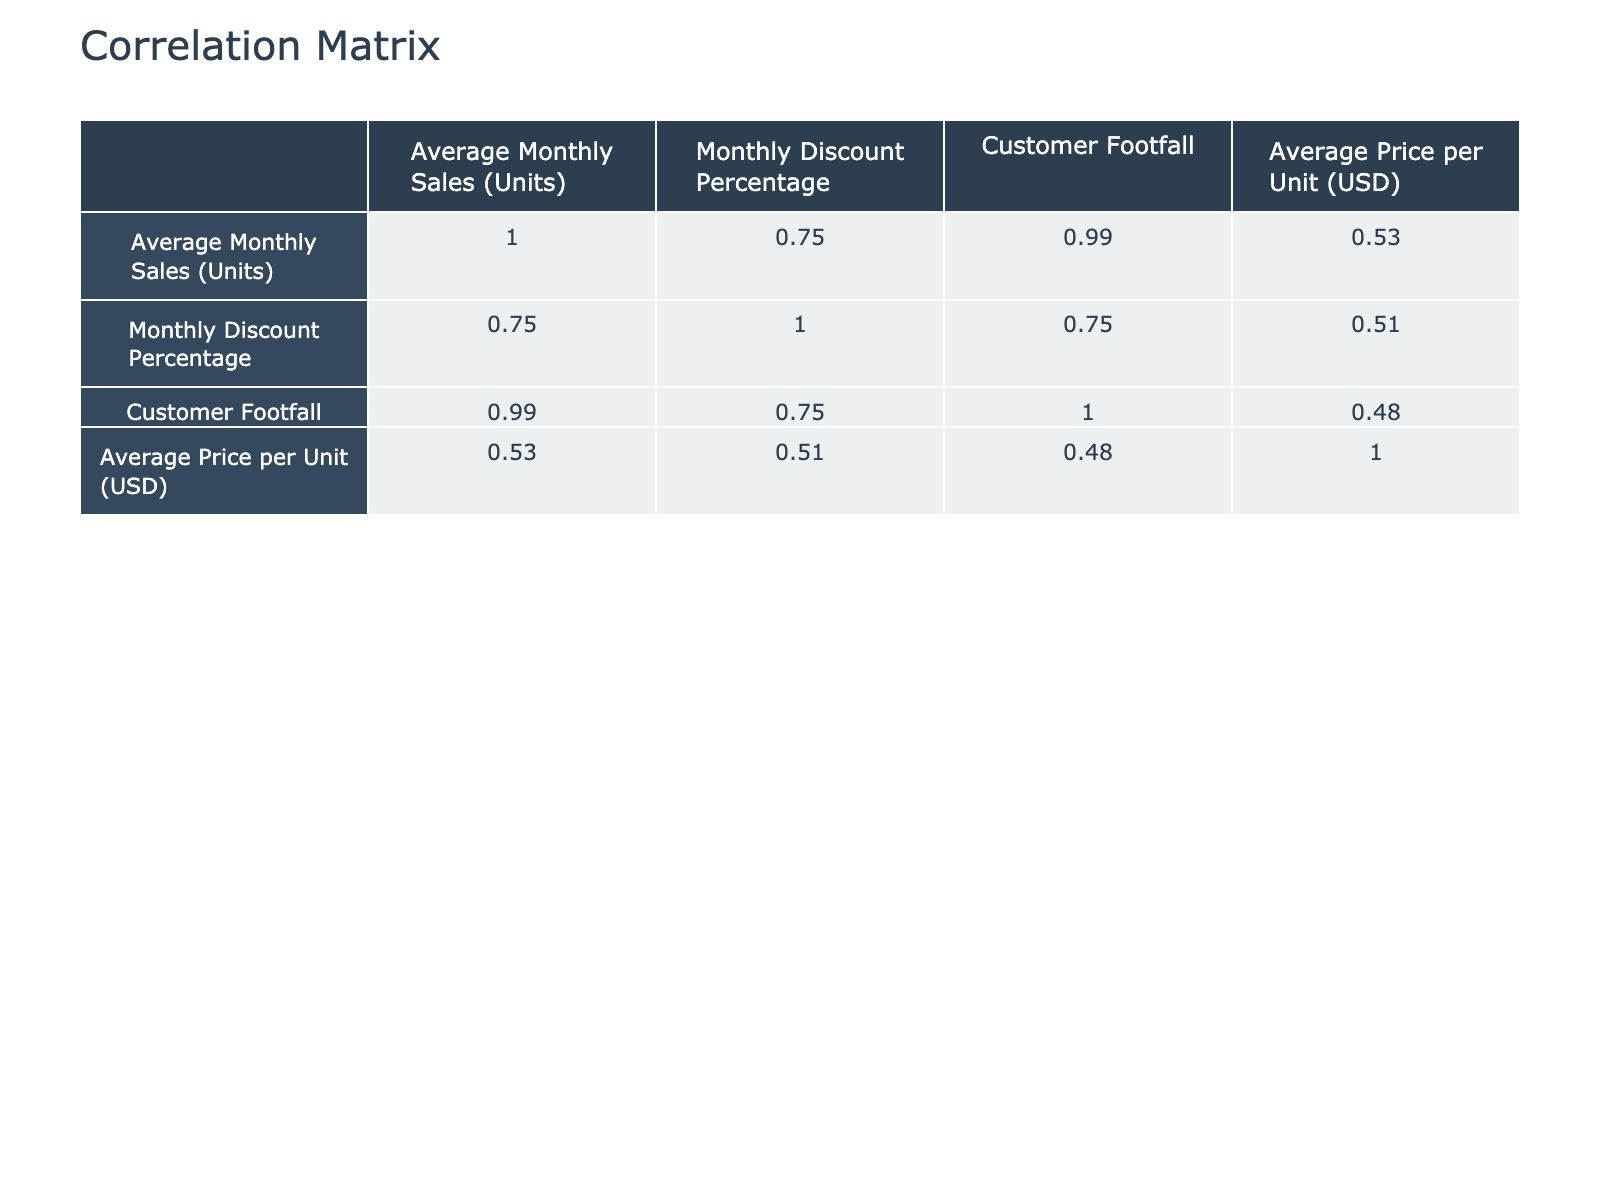What is the average monthly sales for vegetables in the summer? Looking at the table, the average monthly sales for vegetables in the summer is explicitly listed as 2200 units.
Answer: 2200 Which season had the highest average customer footfall? By examining the customer footfall values, summer has the highest value at 30000, while the other seasons have lower numbers, indicating summer has the peak footfall.
Answer: Summer Is there a correlation between the average price per unit and the average monthly sales? To determine correlation, we compare the values in both columns. The price varies, but sales do not consistently rise or fall with price. Correlation calculations confirm a weak negative correlation.
Answer: No What is the average discount percentage across all seasons for fruits? The discount percentages for fruits in each season are 15, 20, 25, and 10. Adding these gives a total of 70, divided by the 4 seasons results in an average of 17.5.
Answer: 17.5 In which season do vegetables see the lowest monthly sales, and what is that number? Reviewing the average monthly sales for vegetables, we see that winter recorded the lowest at 1200 units.
Answer: Winter, 1200 Were discounts for fruits higher in spring than in fall? The discount for fruits in spring is 20%, while in fall, it is 10%. Therefore, spring has a higher discount on fruits compared to fall.
Answer: Yes What is the difference in average monthly sales of fruits between summer and fall? The average monthly sales for fruits in summer is 2500, and in fall, it is 1900. The difference is calculated as 2500 - 1900, which equals 600.
Answer: 600 Does a higher customer footfall correlate with higher sales across all seasons? Analyzing sales and footfall data shows that increases in footfall generally coincide with increases in sales, but not uniformly. Correlation tests show a positive relationship.
Answer: Yes Which product category had the highest average price per unit, and what was the price? Looking at the average price per unit for each category, fruits had the highest average price at 1.50.
Answer: Fruits, 1.50 